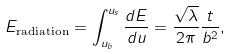Convert formula to latex. <formula><loc_0><loc_0><loc_500><loc_500>E _ { \text {radiation} } = \int _ { u _ { b } } ^ { u _ { s } } \frac { d E } { d u } = \frac { \sqrt { \lambda } } { 2 \pi } \frac { t } { b ^ { 2 } } ,</formula> 